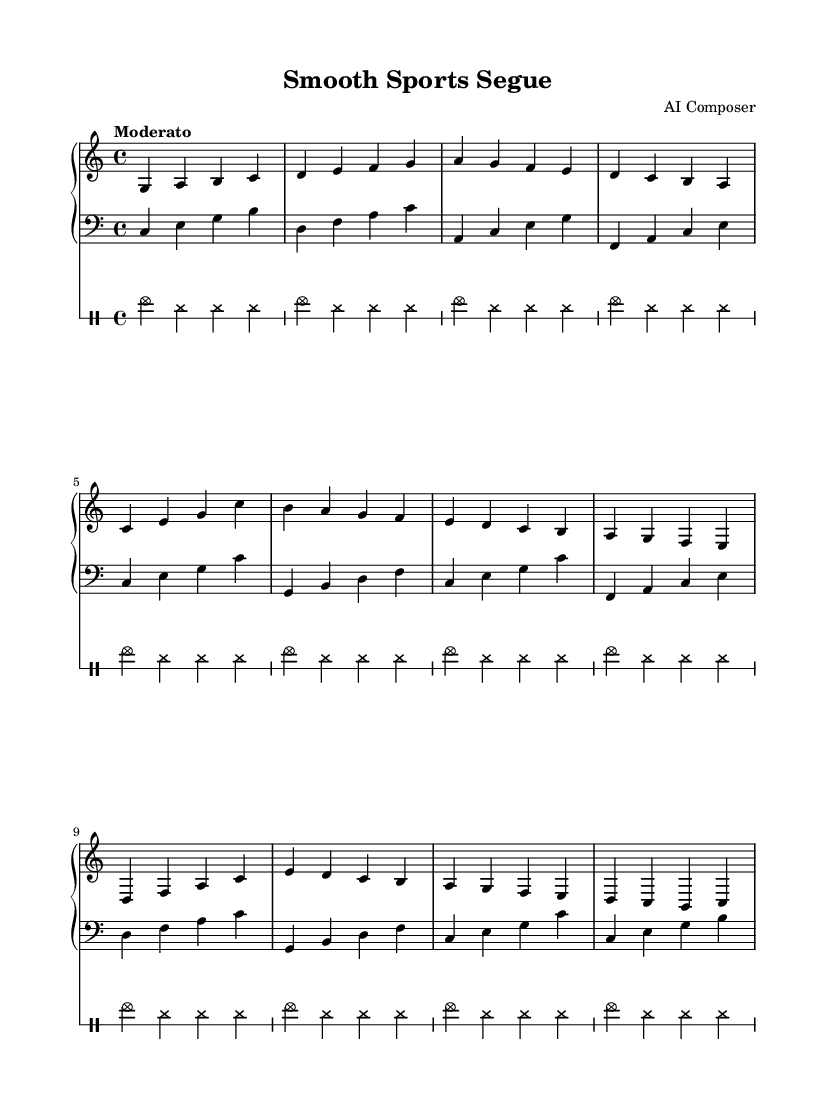What is the key signature of this music? The key signature shown in the music is C major, which indicates that there are no sharps or flats in the scale.
Answer: C major What is the time signature of this music? The time signature is indicated at the beginning of the music as 4/4, meaning there are four beats per measure.
Answer: 4/4 What is the tempo marking of this piece? The tempo marking is specified in the music as "Moderato," which typically indicates a moderate pace.
Answer: Moderato How many measures are in the main theme section? The main theme section consists of four measures, as indicated in the score after the introduction.
Answer: Four Which instruments are featured in this piece? The piece features a piano, bass, and drums, as seen in the respective staff notations.
Answer: Piano, bass, drums What is the chord progression in the first measure of the main theme? The first measure of the main theme shows the notes C, E, and G, which together form a C major chord.
Answer: C major How many times does the cymbal hit appear in the introduction section? The cymbal hits appear four times in each measure of the introduction section, totaling 16 hits for four measures.
Answer: Sixteen 